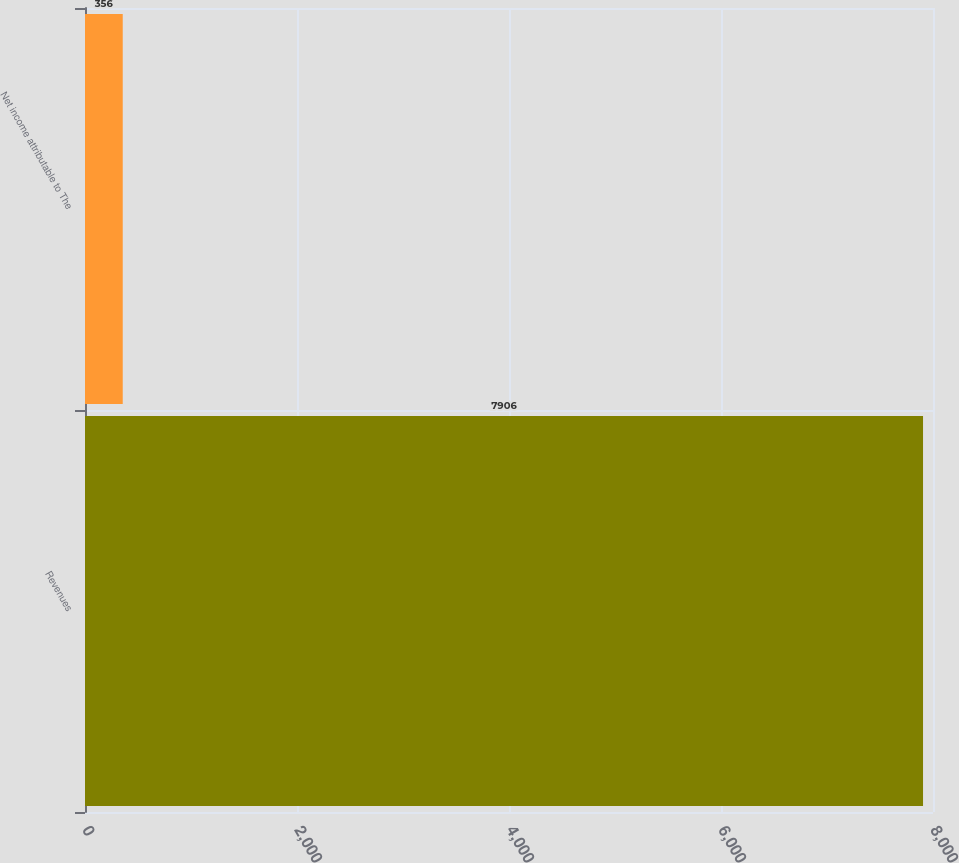Convert chart to OTSL. <chart><loc_0><loc_0><loc_500><loc_500><bar_chart><fcel>Revenues<fcel>Net income attributable to The<nl><fcel>7906<fcel>356<nl></chart> 